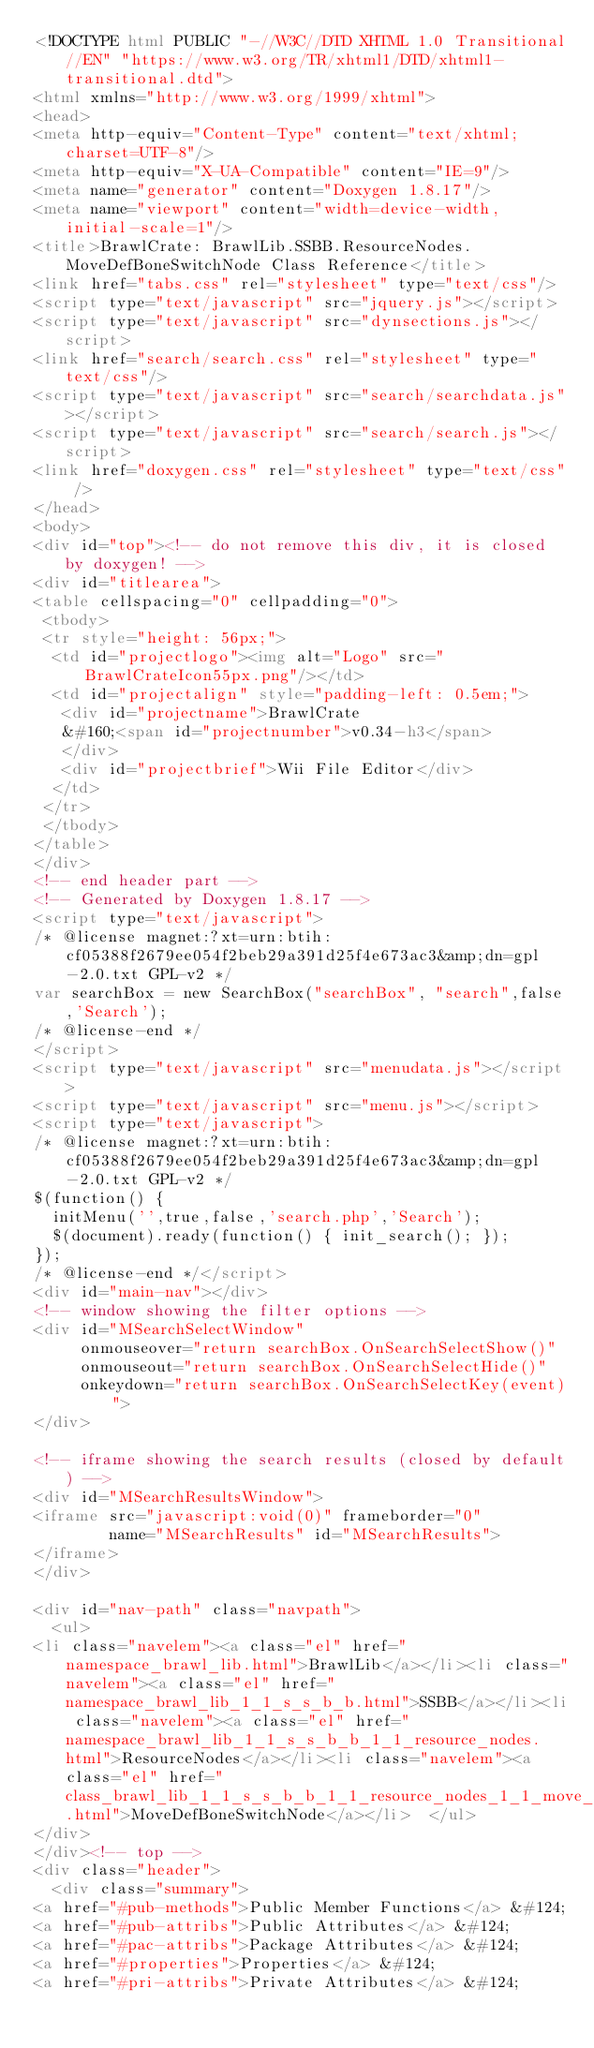<code> <loc_0><loc_0><loc_500><loc_500><_HTML_><!DOCTYPE html PUBLIC "-//W3C//DTD XHTML 1.0 Transitional//EN" "https://www.w3.org/TR/xhtml1/DTD/xhtml1-transitional.dtd">
<html xmlns="http://www.w3.org/1999/xhtml">
<head>
<meta http-equiv="Content-Type" content="text/xhtml;charset=UTF-8"/>
<meta http-equiv="X-UA-Compatible" content="IE=9"/>
<meta name="generator" content="Doxygen 1.8.17"/>
<meta name="viewport" content="width=device-width, initial-scale=1"/>
<title>BrawlCrate: BrawlLib.SSBB.ResourceNodes.MoveDefBoneSwitchNode Class Reference</title>
<link href="tabs.css" rel="stylesheet" type="text/css"/>
<script type="text/javascript" src="jquery.js"></script>
<script type="text/javascript" src="dynsections.js"></script>
<link href="search/search.css" rel="stylesheet" type="text/css"/>
<script type="text/javascript" src="search/searchdata.js"></script>
<script type="text/javascript" src="search/search.js"></script>
<link href="doxygen.css" rel="stylesheet" type="text/css" />
</head>
<body>
<div id="top"><!-- do not remove this div, it is closed by doxygen! -->
<div id="titlearea">
<table cellspacing="0" cellpadding="0">
 <tbody>
 <tr style="height: 56px;">
  <td id="projectlogo"><img alt="Logo" src="BrawlCrateIcon55px.png"/></td>
  <td id="projectalign" style="padding-left: 0.5em;">
   <div id="projectname">BrawlCrate
   &#160;<span id="projectnumber">v0.34-h3</span>
   </div>
   <div id="projectbrief">Wii File Editor</div>
  </td>
 </tr>
 </tbody>
</table>
</div>
<!-- end header part -->
<!-- Generated by Doxygen 1.8.17 -->
<script type="text/javascript">
/* @license magnet:?xt=urn:btih:cf05388f2679ee054f2beb29a391d25f4e673ac3&amp;dn=gpl-2.0.txt GPL-v2 */
var searchBox = new SearchBox("searchBox", "search",false,'Search');
/* @license-end */
</script>
<script type="text/javascript" src="menudata.js"></script>
<script type="text/javascript" src="menu.js"></script>
<script type="text/javascript">
/* @license magnet:?xt=urn:btih:cf05388f2679ee054f2beb29a391d25f4e673ac3&amp;dn=gpl-2.0.txt GPL-v2 */
$(function() {
  initMenu('',true,false,'search.php','Search');
  $(document).ready(function() { init_search(); });
});
/* @license-end */</script>
<div id="main-nav"></div>
<!-- window showing the filter options -->
<div id="MSearchSelectWindow"
     onmouseover="return searchBox.OnSearchSelectShow()"
     onmouseout="return searchBox.OnSearchSelectHide()"
     onkeydown="return searchBox.OnSearchSelectKey(event)">
</div>

<!-- iframe showing the search results (closed by default) -->
<div id="MSearchResultsWindow">
<iframe src="javascript:void(0)" frameborder="0" 
        name="MSearchResults" id="MSearchResults">
</iframe>
</div>

<div id="nav-path" class="navpath">
  <ul>
<li class="navelem"><a class="el" href="namespace_brawl_lib.html">BrawlLib</a></li><li class="navelem"><a class="el" href="namespace_brawl_lib_1_1_s_s_b_b.html">SSBB</a></li><li class="navelem"><a class="el" href="namespace_brawl_lib_1_1_s_s_b_b_1_1_resource_nodes.html">ResourceNodes</a></li><li class="navelem"><a class="el" href="class_brawl_lib_1_1_s_s_b_b_1_1_resource_nodes_1_1_move_def_bone_switch_node.html">MoveDefBoneSwitchNode</a></li>  </ul>
</div>
</div><!-- top -->
<div class="header">
  <div class="summary">
<a href="#pub-methods">Public Member Functions</a> &#124;
<a href="#pub-attribs">Public Attributes</a> &#124;
<a href="#pac-attribs">Package Attributes</a> &#124;
<a href="#properties">Properties</a> &#124;
<a href="#pri-attribs">Private Attributes</a> &#124;</code> 